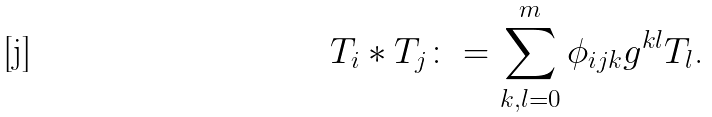Convert formula to latex. <formula><loc_0><loc_0><loc_500><loc_500>T _ { i } * T _ { j } \colon = \sum _ { k , l = 0 } ^ { m } \phi _ { i j k } g ^ { k l } T _ { l } \text {.}</formula> 